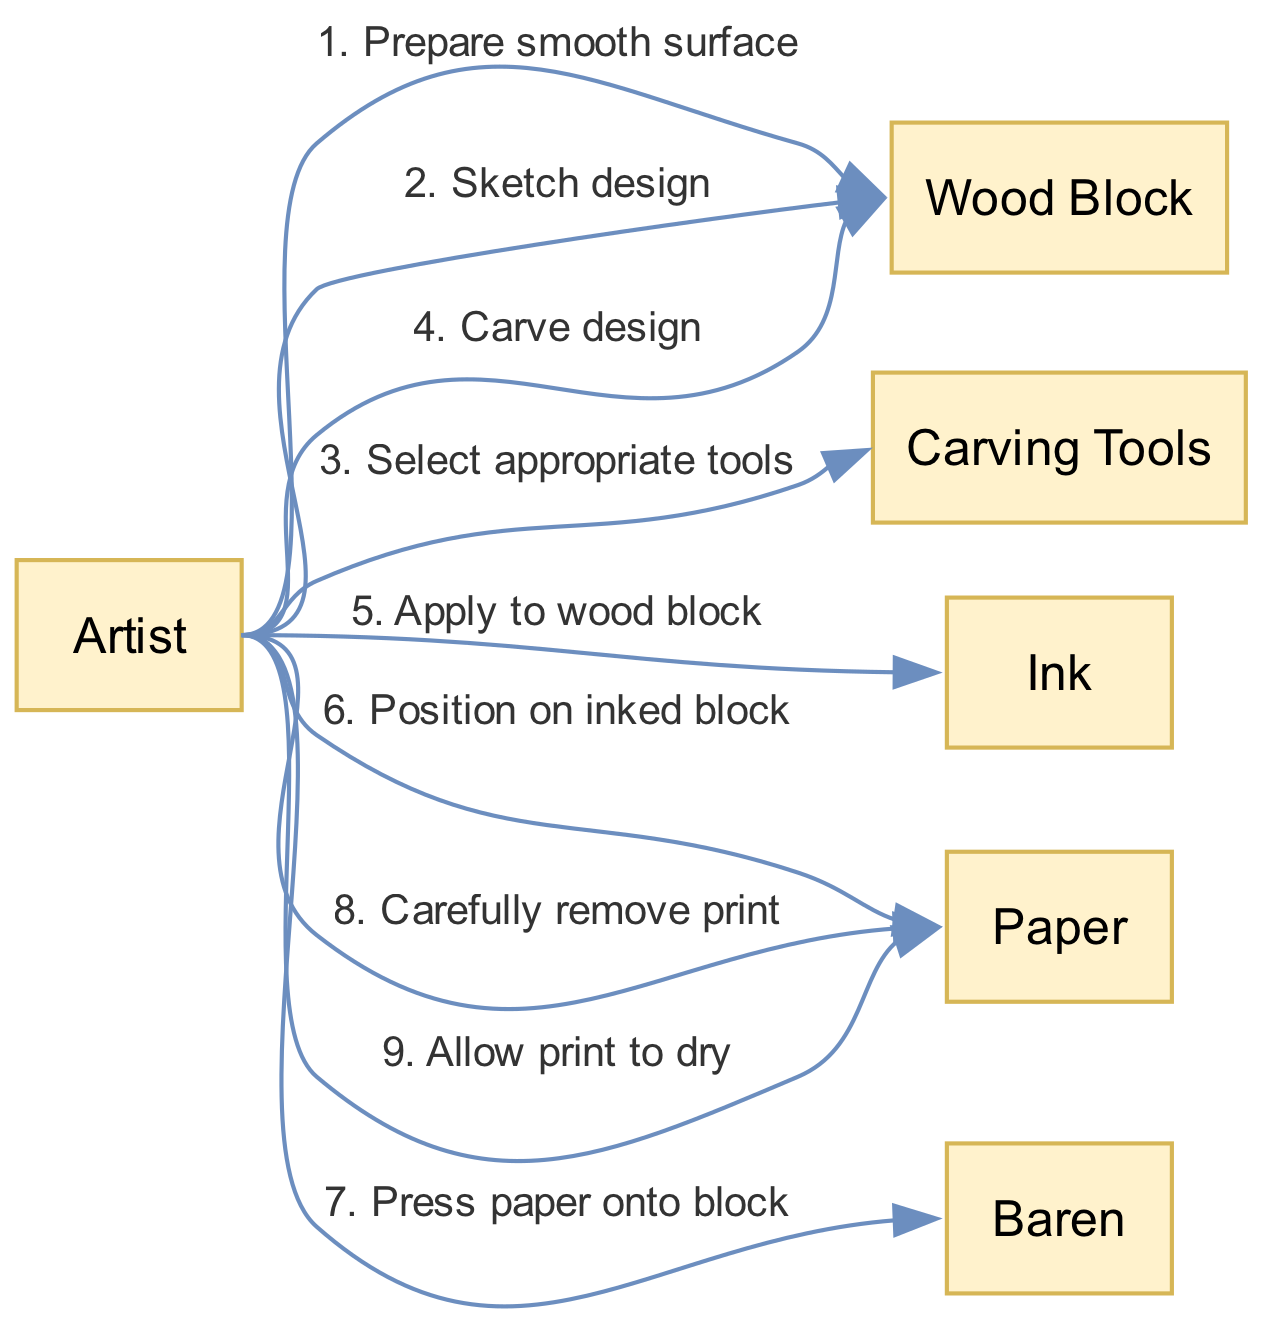What is the first action taken by the Artist? The first action taken by the Artist, according to the sequence, is to "Prepare smooth surface" on the Wood Block. This was the initial step before any design work began.
Answer: Prepare smooth surface How many participants are involved in the process? The diagram lists a total of five participants: Artist, Wood Block, Carving Tools, Ink, and Paper. Each participant represents a crucial element in the woodblock printing process.
Answer: 5 What action is taken after carving the design? After the Artist carves the design on the Wood Block, the next action is to "Apply to wood block" involving Ink. This indicates that the Artist applies ink immediately after carving.
Answer: Apply to wood block Which participant is used to press the paper onto the block? The Baren is the participant used to press the paper onto the inked block, as indicated by the respective action sequence.
Answer: Baren What is the last step in the sequence? The last step in the sequence is "Allow print to dry" involving Paper, marking the completion of the woodblock print process.
Answer: Allow print to dry What actions are performed on the Wood Block? The actions performed on the Wood Block are "Prepare smooth surface," "Sketch design," and "Carve design." These steps outline the preparation and design processes that occur on the Wood Block before printing.
Answer: Prepare smooth surface, Sketch design, Carve design Which action directly precedes the application of ink? The action that directly precedes the application of ink is "Carve design." This clearly indicates that the design must be carved before ink can be applied to the Wood Block.
Answer: Carve design What happens immediately after positioning the paper? Immediately after the Artist positions the paper on the inked block, the next action is to "Press paper onto block" using the Baren. This indicates a sequential flow where positioning leads directly to pressing.
Answer: Press paper onto block 